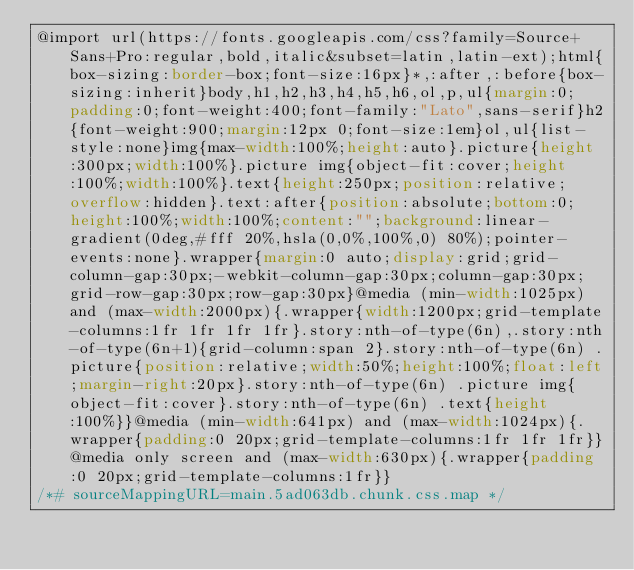<code> <loc_0><loc_0><loc_500><loc_500><_CSS_>@import url(https://fonts.googleapis.com/css?family=Source+Sans+Pro:regular,bold,italic&subset=latin,latin-ext);html{box-sizing:border-box;font-size:16px}*,:after,:before{box-sizing:inherit}body,h1,h2,h3,h4,h5,h6,ol,p,ul{margin:0;padding:0;font-weight:400;font-family:"Lato",sans-serif}h2{font-weight:900;margin:12px 0;font-size:1em}ol,ul{list-style:none}img{max-width:100%;height:auto}.picture{height:300px;width:100%}.picture img{object-fit:cover;height:100%;width:100%}.text{height:250px;position:relative;overflow:hidden}.text:after{position:absolute;bottom:0;height:100%;width:100%;content:"";background:linear-gradient(0deg,#fff 20%,hsla(0,0%,100%,0) 80%);pointer-events:none}.wrapper{margin:0 auto;display:grid;grid-column-gap:30px;-webkit-column-gap:30px;column-gap:30px;grid-row-gap:30px;row-gap:30px}@media (min-width:1025px) and (max-width:2000px){.wrapper{width:1200px;grid-template-columns:1fr 1fr 1fr 1fr}.story:nth-of-type(6n),.story:nth-of-type(6n+1){grid-column:span 2}.story:nth-of-type(6n) .picture{position:relative;width:50%;height:100%;float:left;margin-right:20px}.story:nth-of-type(6n) .picture img{object-fit:cover}.story:nth-of-type(6n) .text{height:100%}}@media (min-width:641px) and (max-width:1024px){.wrapper{padding:0 20px;grid-template-columns:1fr 1fr 1fr}}@media only screen and (max-width:630px){.wrapper{padding:0 20px;grid-template-columns:1fr}}
/*# sourceMappingURL=main.5ad063db.chunk.css.map */</code> 